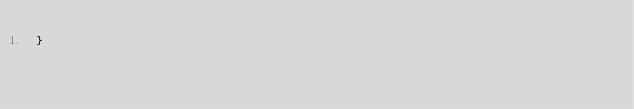<code> <loc_0><loc_0><loc_500><loc_500><_JavaScript_>}
</code> 